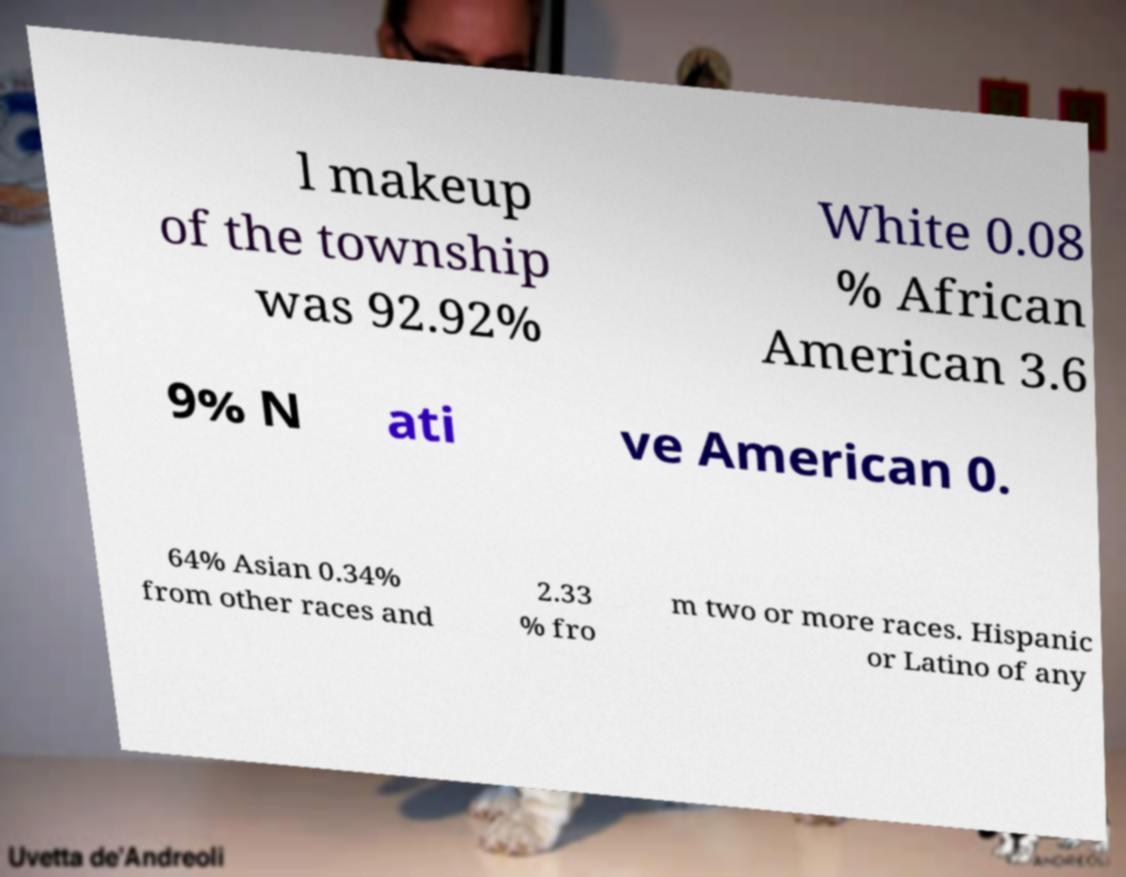For documentation purposes, I need the text within this image transcribed. Could you provide that? l makeup of the township was 92.92% White 0.08 % African American 3.6 9% N ati ve American 0. 64% Asian 0.34% from other races and 2.33 % fro m two or more races. Hispanic or Latino of any 